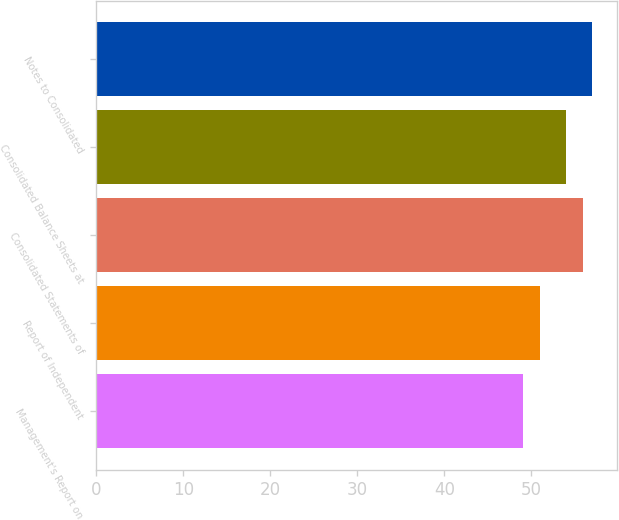Convert chart to OTSL. <chart><loc_0><loc_0><loc_500><loc_500><bar_chart><fcel>Management's Report on<fcel>Report of Independent<fcel>Consolidated Statements of<fcel>Consolidated Balance Sheets at<fcel>Notes to Consolidated<nl><fcel>49<fcel>51<fcel>56<fcel>54<fcel>57<nl></chart> 